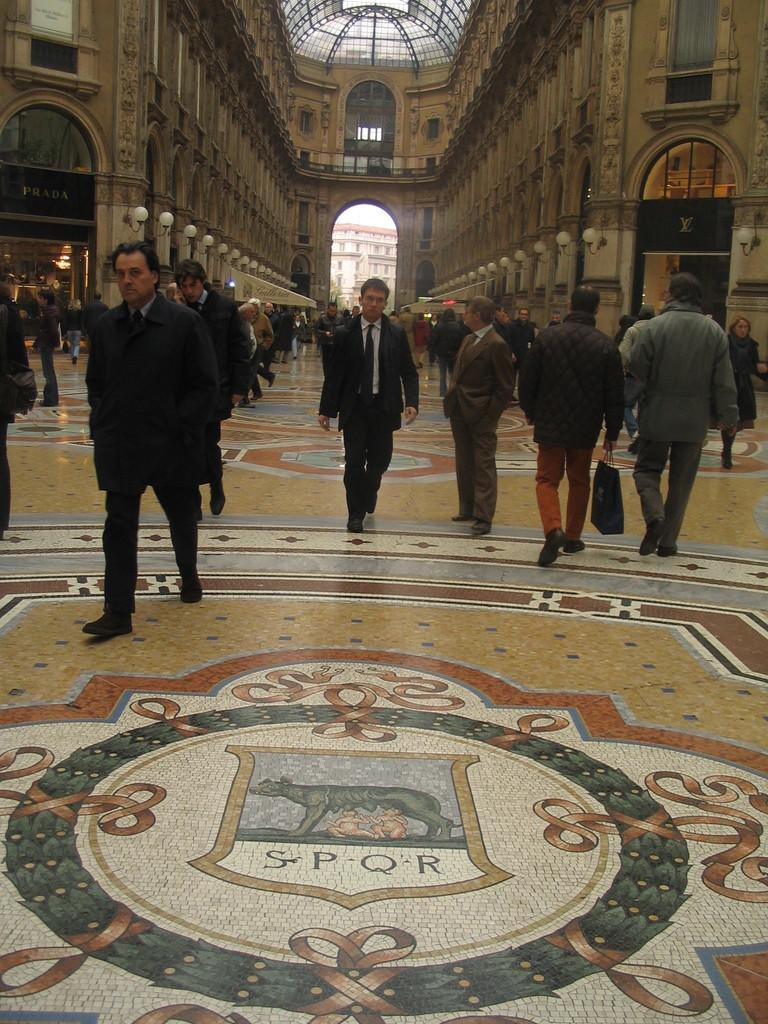What is placed on the floor in the image? There is a painting on the floor in the image. What is happening in the middle of the image? There are people walking in the middle of the image. What can be seen in the background of the image? There is a big building at the back side of the image. How many pigs are being held in the prison in the image? There is no prison or pigs present in the image. 